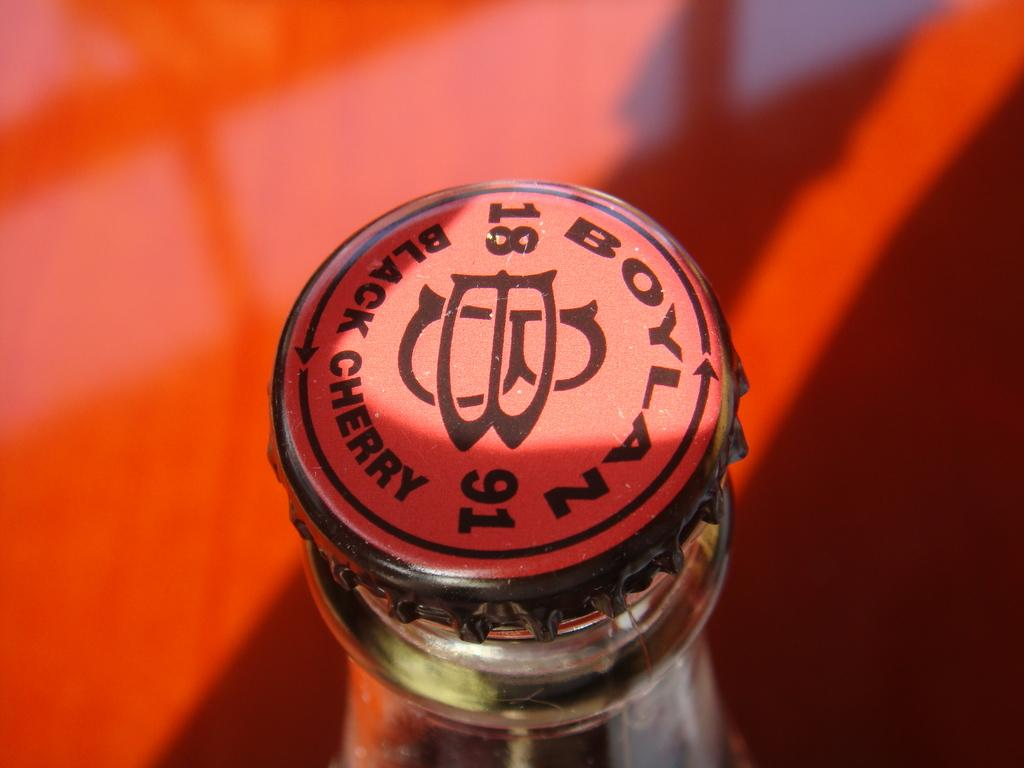<image>
Relay a brief, clear account of the picture shown. A Boylan black cherry soda bottle with the year 1891 on the cap. 